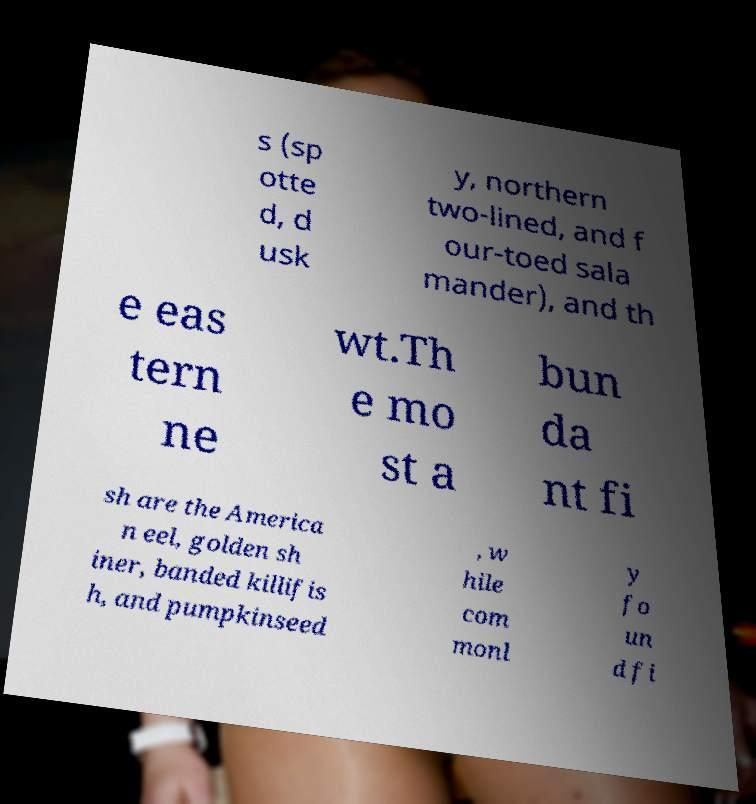Please read and relay the text visible in this image. What does it say? s (sp otte d, d usk y, northern two-lined, and f our-toed sala mander), and th e eas tern ne wt.Th e mo st a bun da nt fi sh are the America n eel, golden sh iner, banded killifis h, and pumpkinseed , w hile com monl y fo un d fi 